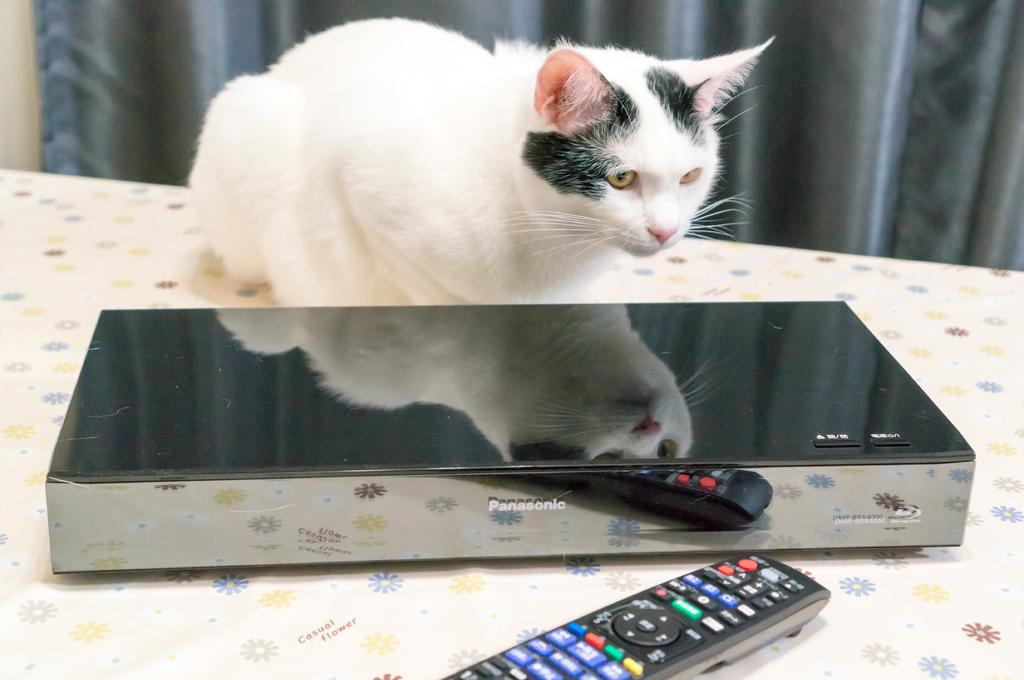What is the main object in the center of the image? There is a table in the center of the image. What electronic device is on the table? There is a disc player on the table. What might be used to control the disc player? There is a remote on the table. What animal is present on the table? There is a cat on the table. What can be seen in the background of the image? There is a curtain in the background of the image. What type of root can be seen growing from the cat in the image? There is no root growing from the cat in the image; it is a cat, not a plant. 